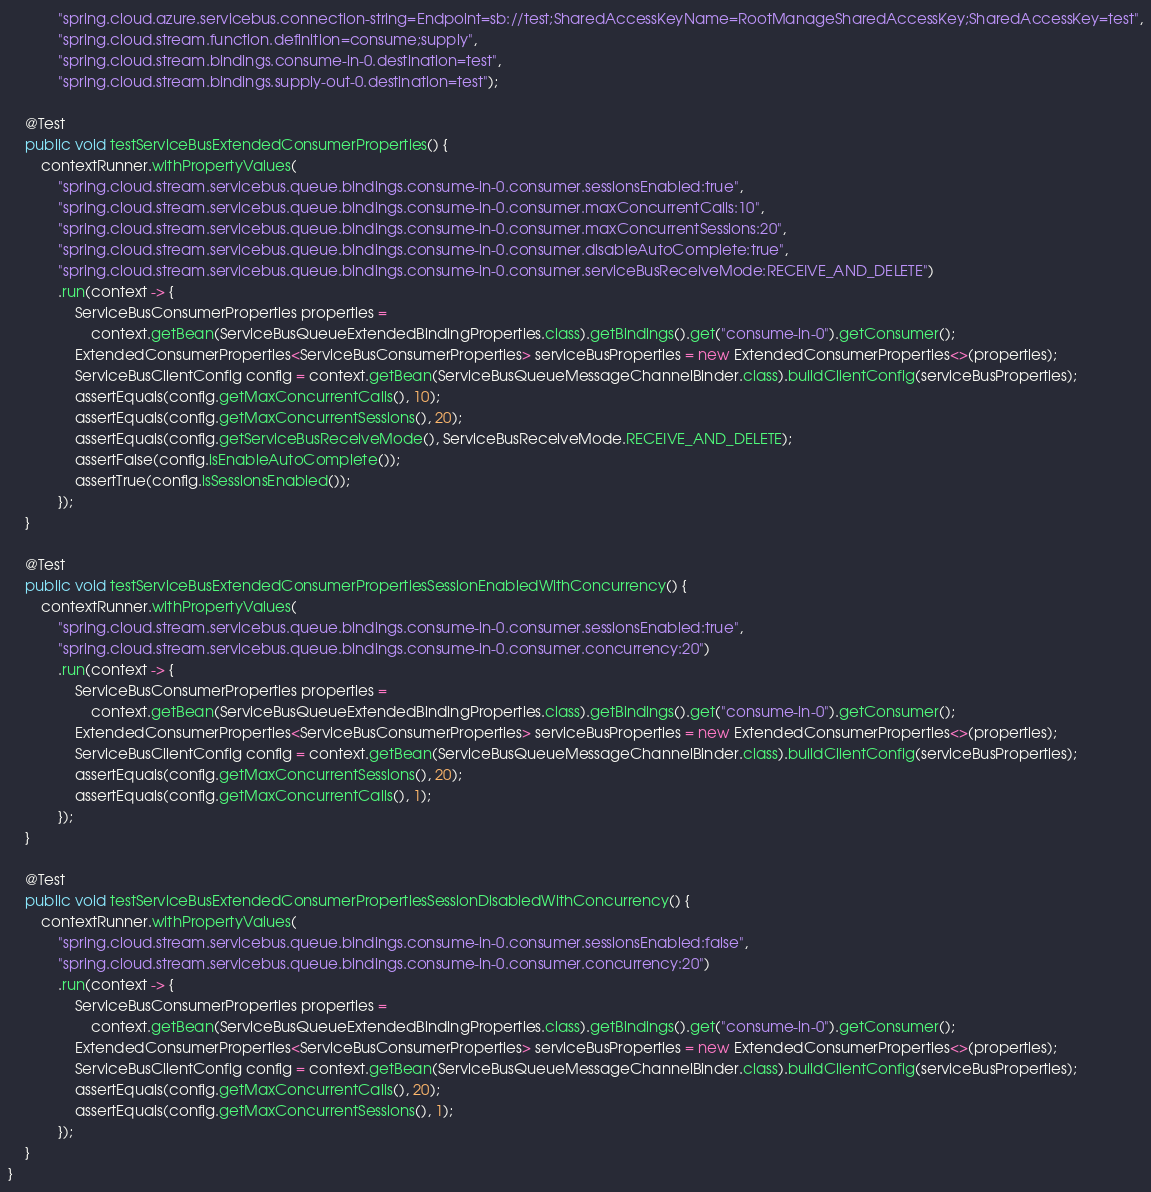Convert code to text. <code><loc_0><loc_0><loc_500><loc_500><_Java_>            "spring.cloud.azure.servicebus.connection-string=Endpoint=sb://test;SharedAccessKeyName=RootManageSharedAccessKey;SharedAccessKey=test",
            "spring.cloud.stream.function.definition=consume;supply",
            "spring.cloud.stream.bindings.consume-in-0.destination=test",
            "spring.cloud.stream.bindings.supply-out-0.destination=test");

    @Test
    public void testServiceBusExtendedConsumerProperties() {
        contextRunner.withPropertyValues(
            "spring.cloud.stream.servicebus.queue.bindings.consume-in-0.consumer.sessionsEnabled:true",
            "spring.cloud.stream.servicebus.queue.bindings.consume-in-0.consumer.maxConcurrentCalls:10",
            "spring.cloud.stream.servicebus.queue.bindings.consume-in-0.consumer.maxConcurrentSessions:20",
            "spring.cloud.stream.servicebus.queue.bindings.consume-in-0.consumer.disableAutoComplete:true",
            "spring.cloud.stream.servicebus.queue.bindings.consume-in-0.consumer.serviceBusReceiveMode:RECEIVE_AND_DELETE")
            .run(context -> {
                ServiceBusConsumerProperties properties =
                    context.getBean(ServiceBusQueueExtendedBindingProperties.class).getBindings().get("consume-in-0").getConsumer();
                ExtendedConsumerProperties<ServiceBusConsumerProperties> serviceBusProperties = new ExtendedConsumerProperties<>(properties);
                ServiceBusClientConfig config = context.getBean(ServiceBusQueueMessageChannelBinder.class).buildClientConfig(serviceBusProperties);
                assertEquals(config.getMaxConcurrentCalls(), 10);
                assertEquals(config.getMaxConcurrentSessions(), 20);
                assertEquals(config.getServiceBusReceiveMode(), ServiceBusReceiveMode.RECEIVE_AND_DELETE);
                assertFalse(config.isEnableAutoComplete());
                assertTrue(config.isSessionsEnabled());
            });
    }

    @Test
    public void testServiceBusExtendedConsumerPropertiesSessionEnabledWithConcurrency() {
        contextRunner.withPropertyValues(
            "spring.cloud.stream.servicebus.queue.bindings.consume-in-0.consumer.sessionsEnabled:true",
            "spring.cloud.stream.servicebus.queue.bindings.consume-in-0.consumer.concurrency:20")
            .run(context -> {
                ServiceBusConsumerProperties properties =
                    context.getBean(ServiceBusQueueExtendedBindingProperties.class).getBindings().get("consume-in-0").getConsumer();
                ExtendedConsumerProperties<ServiceBusConsumerProperties> serviceBusProperties = new ExtendedConsumerProperties<>(properties);
                ServiceBusClientConfig config = context.getBean(ServiceBusQueueMessageChannelBinder.class).buildClientConfig(serviceBusProperties);
                assertEquals(config.getMaxConcurrentSessions(), 20);
                assertEquals(config.getMaxConcurrentCalls(), 1);
            });
    }

    @Test
    public void testServiceBusExtendedConsumerPropertiesSessionDisabledWithConcurrency() {
        contextRunner.withPropertyValues(
            "spring.cloud.stream.servicebus.queue.bindings.consume-in-0.consumer.sessionsEnabled:false",
            "spring.cloud.stream.servicebus.queue.bindings.consume-in-0.consumer.concurrency:20")
            .run(context -> {
                ServiceBusConsumerProperties properties =
                    context.getBean(ServiceBusQueueExtendedBindingProperties.class).getBindings().get("consume-in-0").getConsumer();
                ExtendedConsumerProperties<ServiceBusConsumerProperties> serviceBusProperties = new ExtendedConsumerProperties<>(properties);
                ServiceBusClientConfig config = context.getBean(ServiceBusQueueMessageChannelBinder.class).buildClientConfig(serviceBusProperties);
                assertEquals(config.getMaxConcurrentCalls(), 20);
                assertEquals(config.getMaxConcurrentSessions(), 1);
            });
    }
}
</code> 